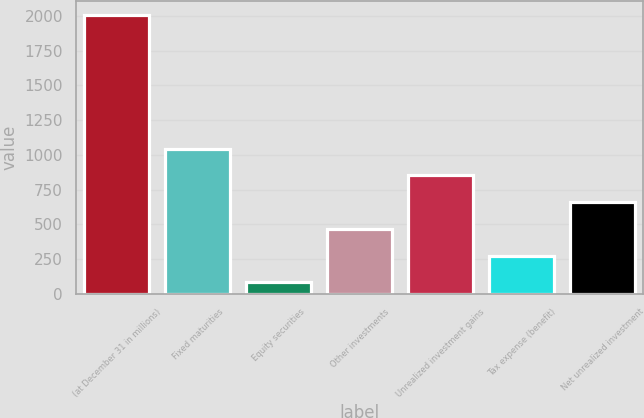Convert chart. <chart><loc_0><loc_0><loc_500><loc_500><bar_chart><fcel>(at December 31 in millions)<fcel>Fixed maturities<fcel>Equity securities<fcel>Other investments<fcel>Unrealized investment gains<fcel>Tax expense (benefit)<fcel>Net unrealized investment<nl><fcel>2008<fcel>1045<fcel>82<fcel>467.2<fcel>852.4<fcel>274.6<fcel>659.8<nl></chart> 